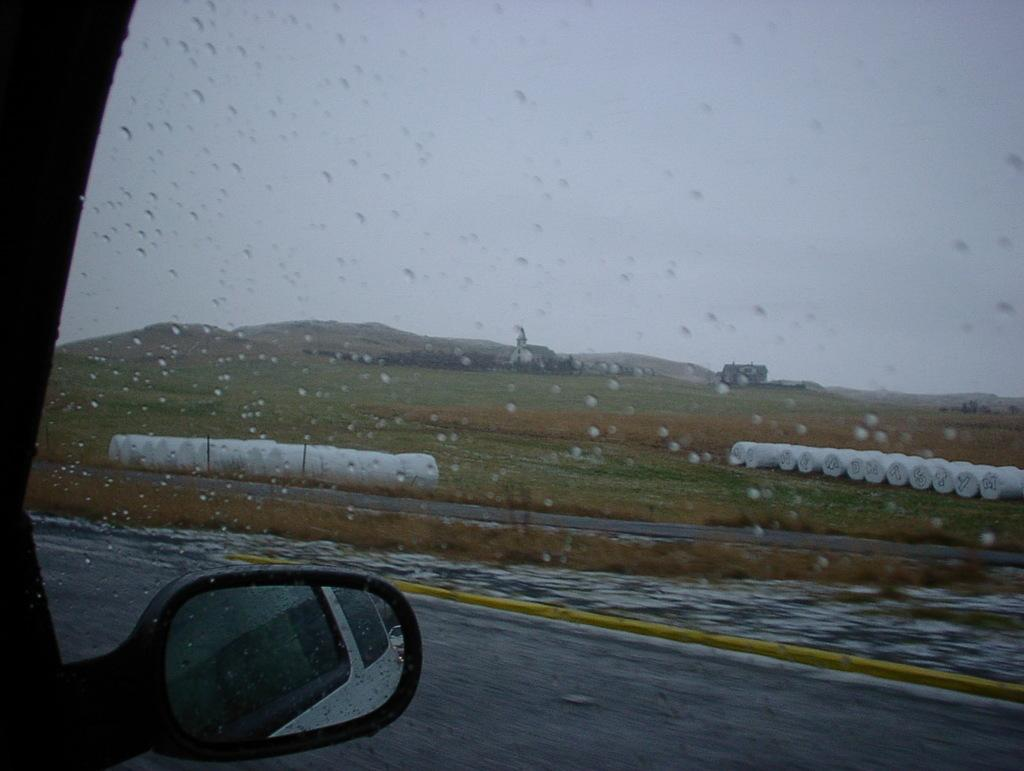What is the main subject of the image? The main subject of the image is a vehicle window glass with water droplets. What is located behind the window glass? There is a mirror behind the window glass. What type of vegetation can be seen in the image? There is grass on the ground in the image. What color are the objects on the ground? The white objects on the ground are visible in the image. What other items can be seen on the ground? There are other items visible on the ground. Can you tell me how many noses are visible in the image? There are no noses visible in the image. What type of leaf can be seen falling from the sky in the image? There is no leaf falling from the sky in the image. 